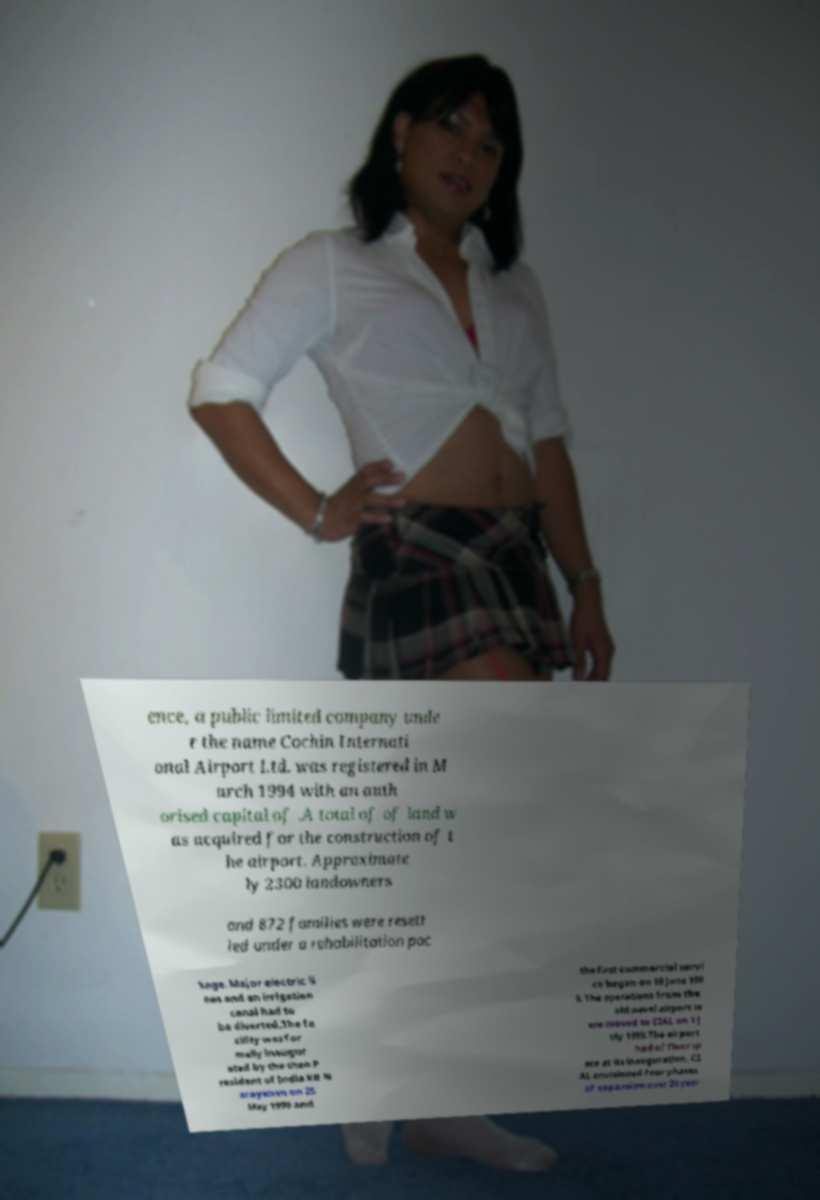I need the written content from this picture converted into text. Can you do that? ence, a public limited company unde r the name Cochin Internati onal Airport Ltd. was registered in M arch 1994 with an auth orised capital of .A total of of land w as acquired for the construction of t he airport. Approximate ly 2300 landowners and 872 families were resett led under a rehabilitation pac kage. Major electric li nes and an irrigation canal had to be diverted.The fa cility was for mally inaugur ated by the then P resident of India KR N arayanan on 25 May 1999 and the first commercial servi ce began on 10 June 199 9. The operations from the old naval airport w ere moved to CIAL on 1 J uly 1999.The airport had of floor sp ace at its inauguration. CI AL envisioned four phases of expansion over 20 year 